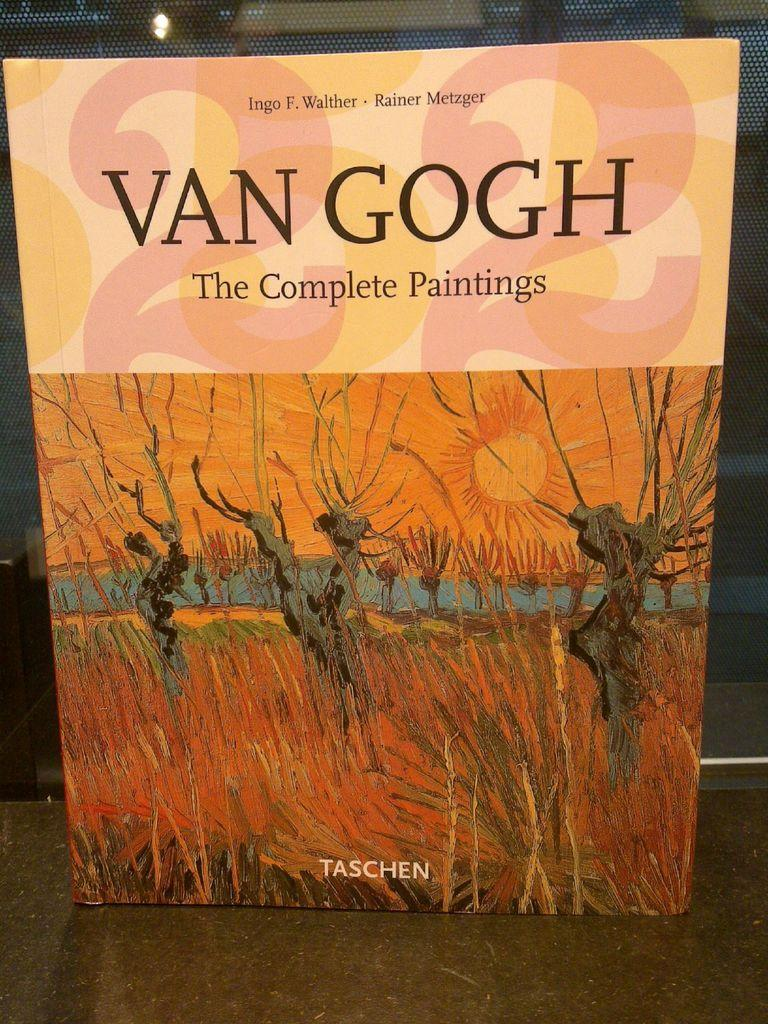<image>
Summarize the visual content of the image. A book named The Complete Paintings by Van Gogh that is placed upright on a surface. 